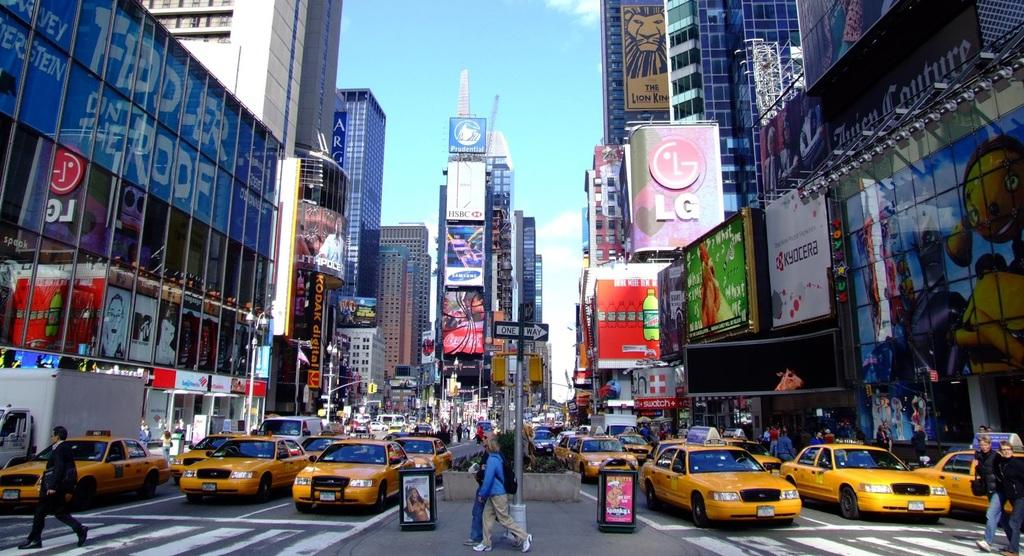<image>
Write a terse but informative summary of the picture. The phone company LG ha a large sign on the right which is also reflected on the left. 